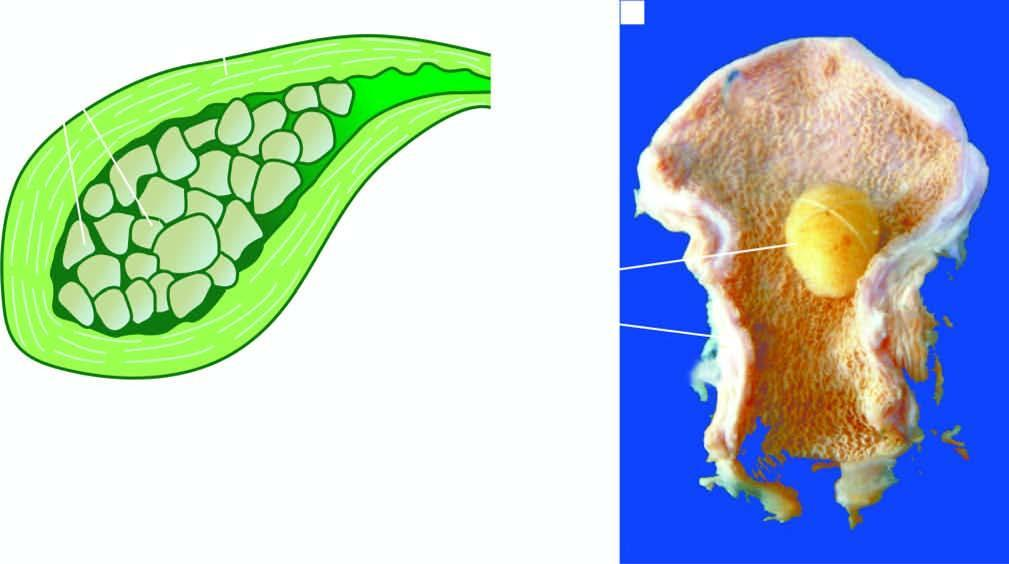what is thickened?
Answer the question using a single word or phrase. Wall of the gallbladder 